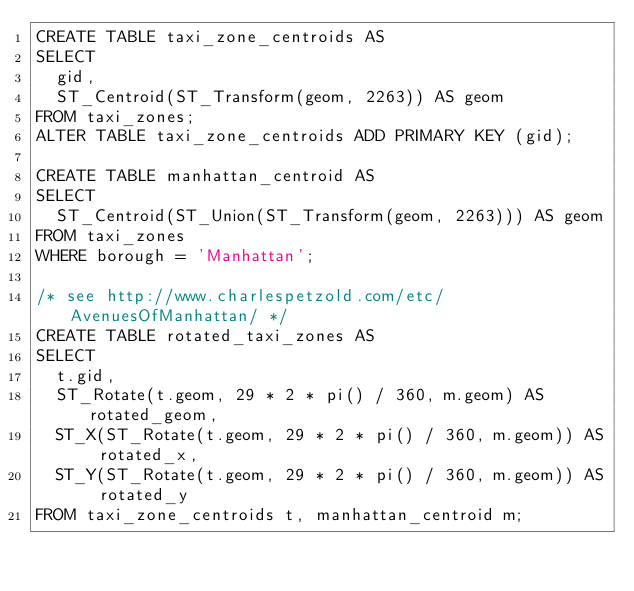<code> <loc_0><loc_0><loc_500><loc_500><_SQL_>CREATE TABLE taxi_zone_centroids AS
SELECT
  gid,
  ST_Centroid(ST_Transform(geom, 2263)) AS geom
FROM taxi_zones;
ALTER TABLE taxi_zone_centroids ADD PRIMARY KEY (gid);

CREATE TABLE manhattan_centroid AS
SELECT
  ST_Centroid(ST_Union(ST_Transform(geom, 2263))) AS geom
FROM taxi_zones
WHERE borough = 'Manhattan';

/* see http://www.charlespetzold.com/etc/AvenuesOfManhattan/ */
CREATE TABLE rotated_taxi_zones AS
SELECT
  t.gid,
  ST_Rotate(t.geom, 29 * 2 * pi() / 360, m.geom) AS rotated_geom,
  ST_X(ST_Rotate(t.geom, 29 * 2 * pi() / 360, m.geom)) AS rotated_x,
  ST_Y(ST_Rotate(t.geom, 29 * 2 * pi() / 360, m.geom)) AS rotated_y
FROM taxi_zone_centroids t, manhattan_centroid m;</code> 